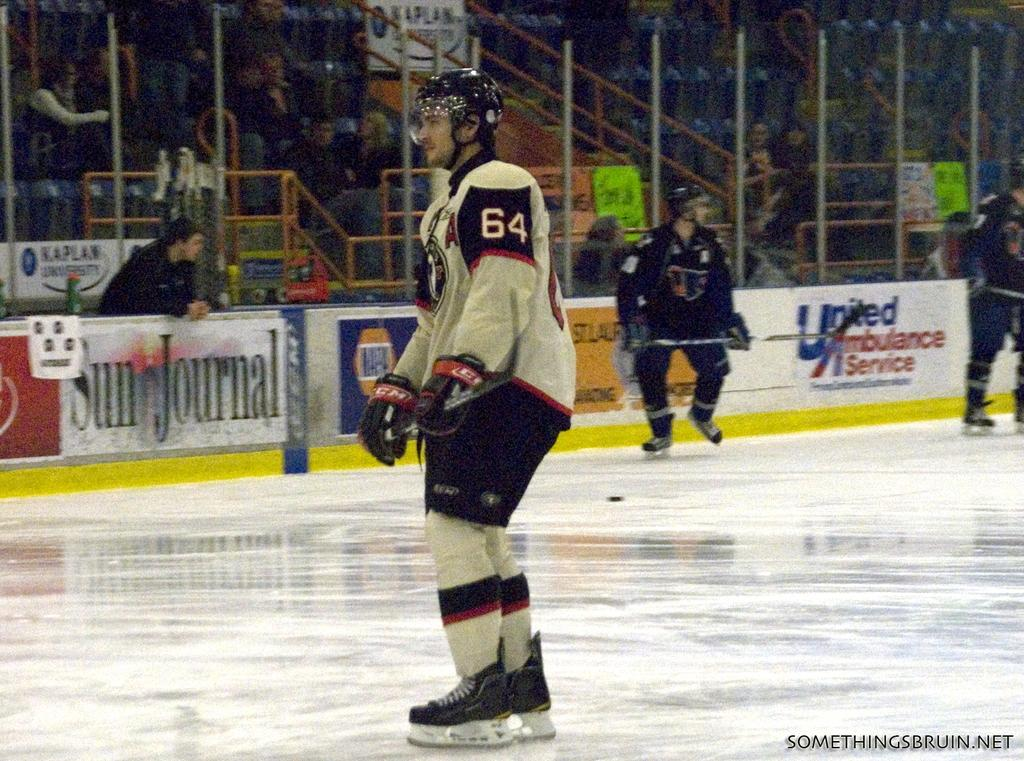Provide a one-sentence caption for the provided image. Hocket player number 64 stands on the ice with a Sun Journal advertisement behind him. 